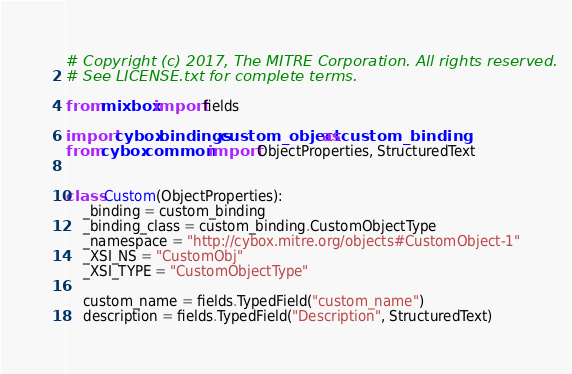Convert code to text. <code><loc_0><loc_0><loc_500><loc_500><_Python_># Copyright (c) 2017, The MITRE Corporation. All rights reserved.
# See LICENSE.txt for complete terms.

from mixbox import fields

import cybox.bindings.custom_object as custom_binding
from cybox.common import ObjectProperties, StructuredText


class Custom(ObjectProperties):
    _binding = custom_binding
    _binding_class = custom_binding.CustomObjectType
    _namespace = "http://cybox.mitre.org/objects#CustomObject-1"
    _XSI_NS = "CustomObj"
    _XSI_TYPE = "CustomObjectType"

    custom_name = fields.TypedField("custom_name")
    description = fields.TypedField("Description", StructuredText)
</code> 